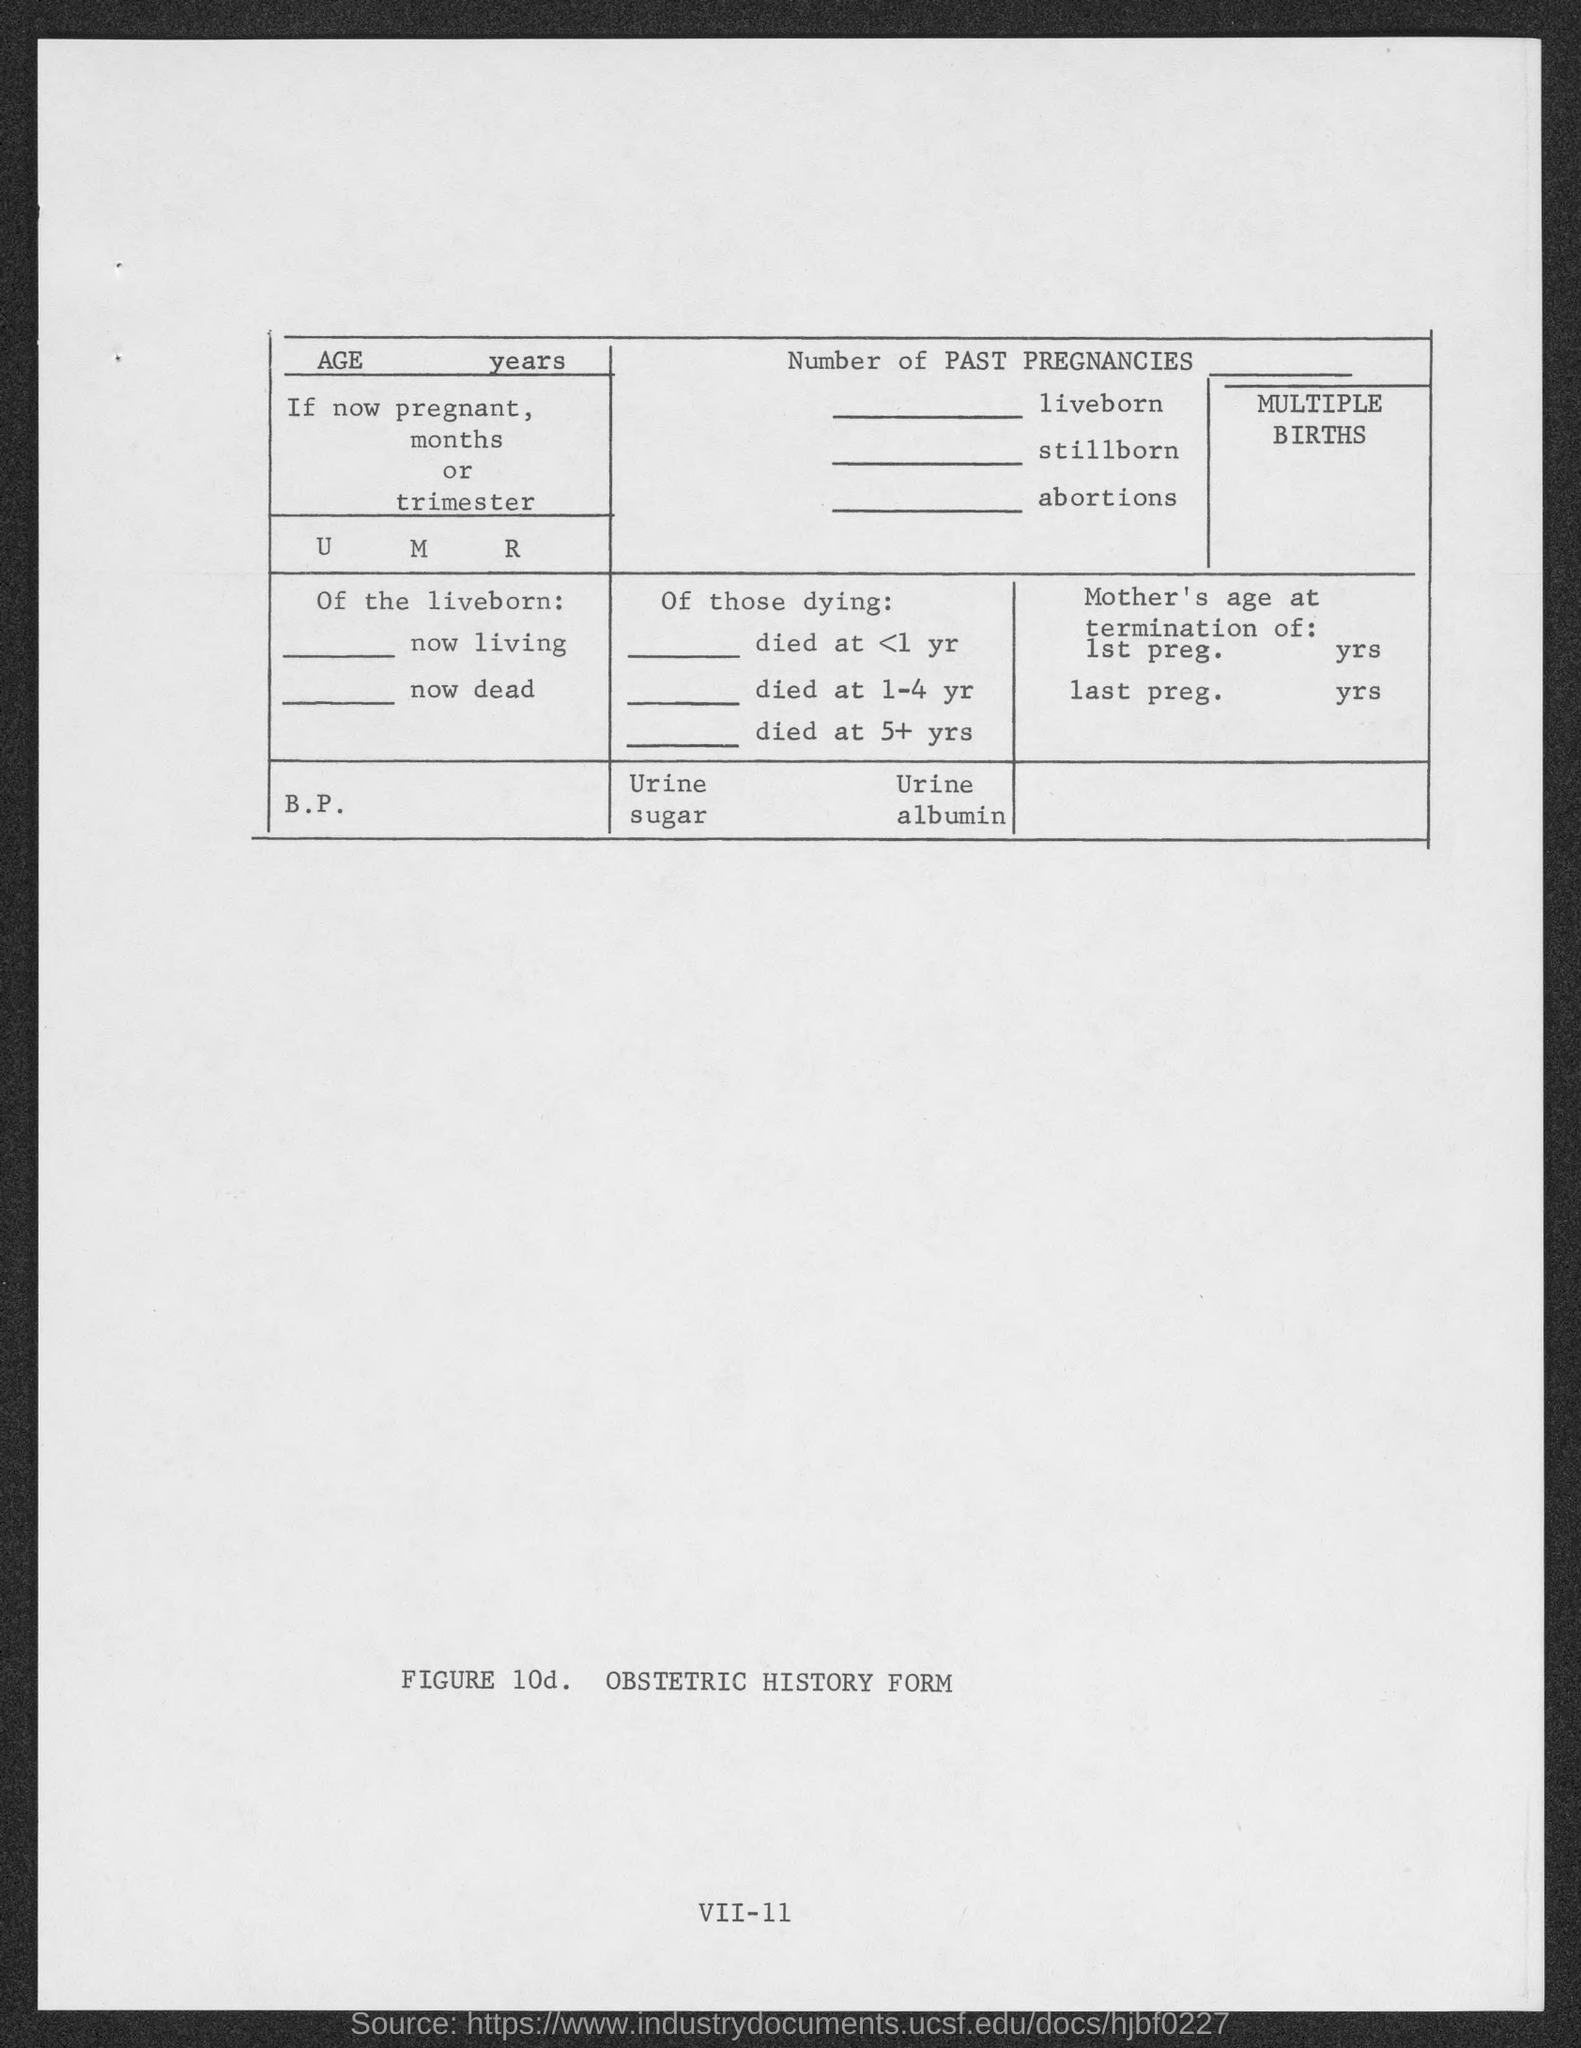Draw attention to some important aspects in this diagram. The name of the form is obstetric history form. 